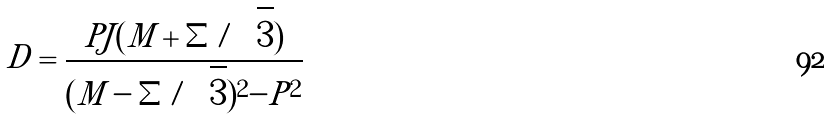<formula> <loc_0><loc_0><loc_500><loc_500>D = \frac { P J ( M + \Sigma / \sqrt { 3 } ) } { ( M - \Sigma / \sqrt { 3 } ) ^ { 2 } - P ^ { 2 } }</formula> 